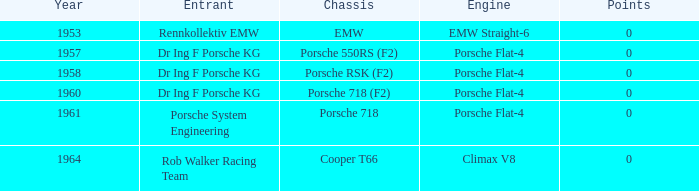In what year did the points exceed 0? 0.0. 